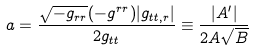Convert formula to latex. <formula><loc_0><loc_0><loc_500><loc_500>a = { \frac { \sqrt { - g _ { r r } } ( - g ^ { r r } ) | g _ { t t , r } | } { 2 g _ { t t } } } \equiv \frac { | A ^ { \prime } | } { 2 A \sqrt { B } }</formula> 